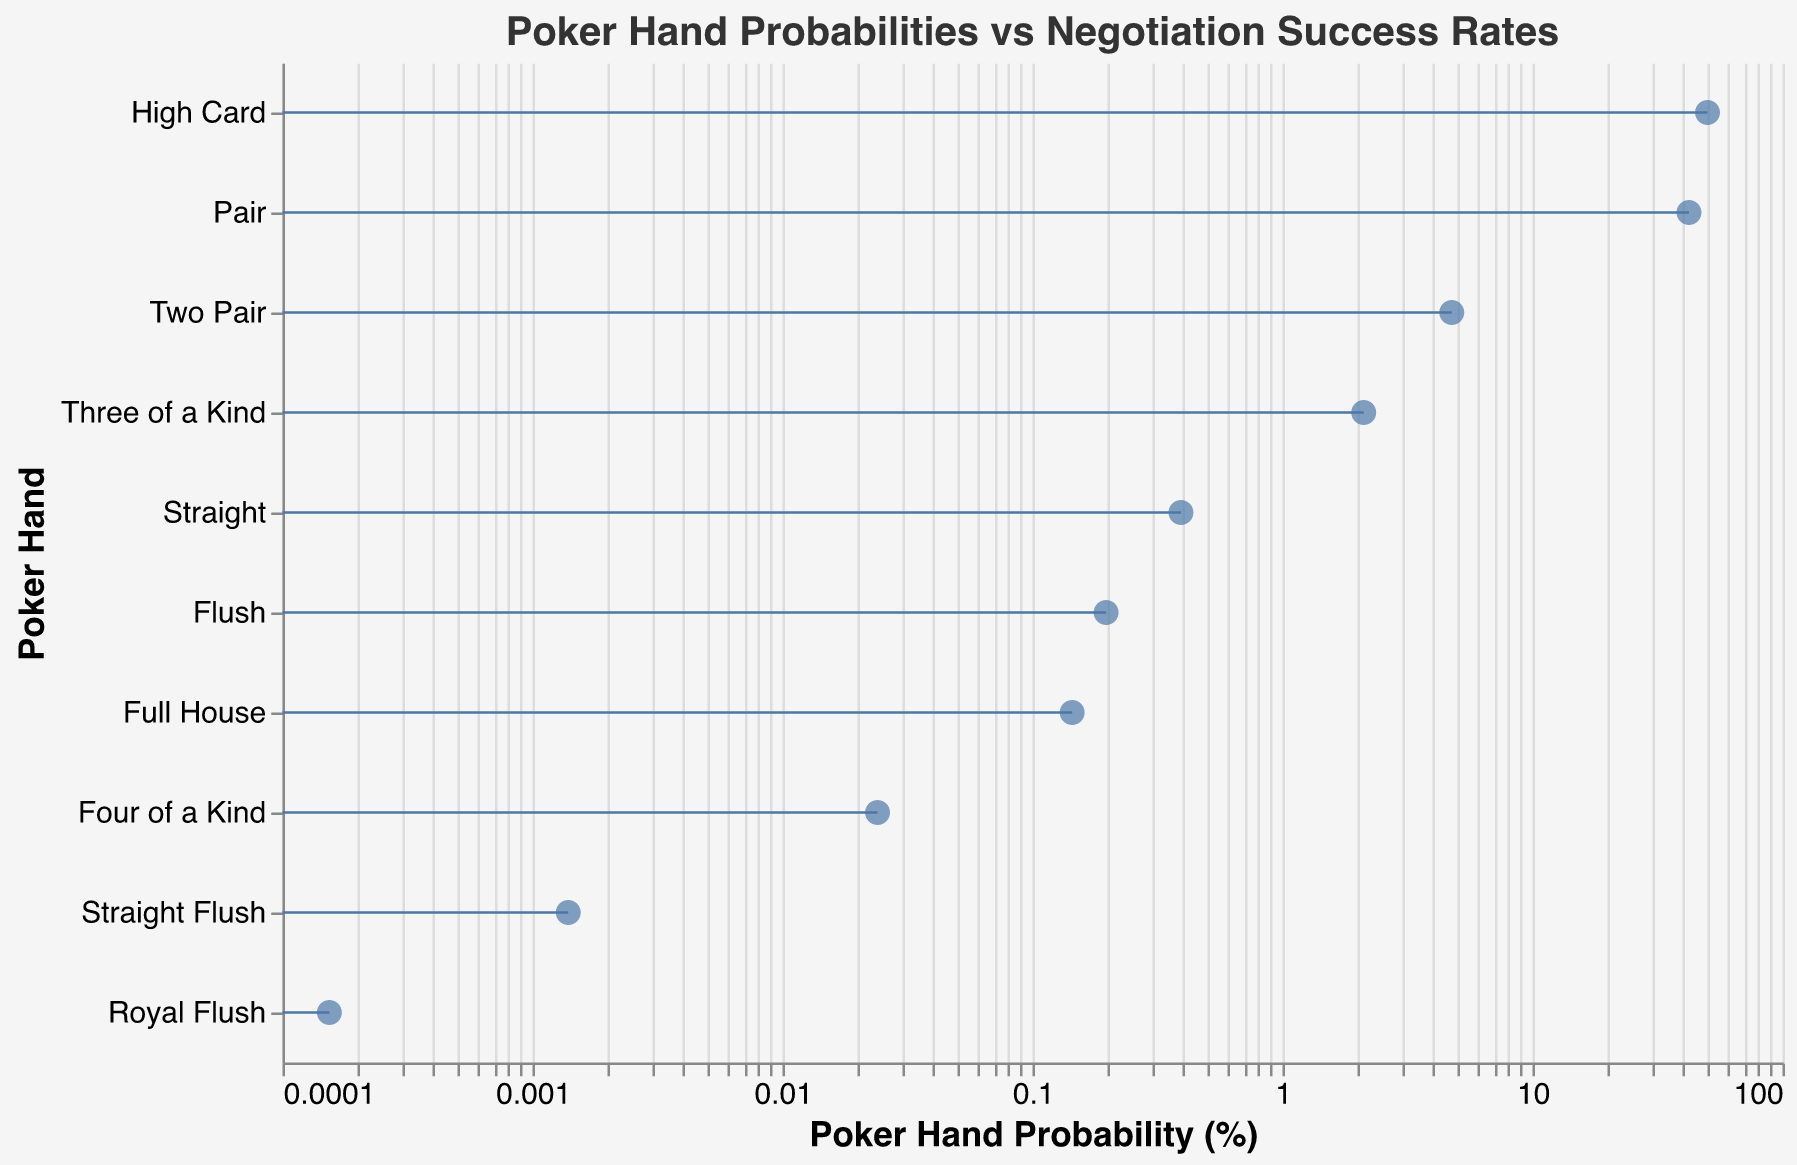What is the title of the figure? The title is usually displayed at the top of the figure and is meant to give a concise summary of what the figure is about. It is easily identifiable by its placement and font size. The title of the figure is "Poker Hand Probabilities vs Negotiation Success Rates".
Answer: Poker Hand Probabilities vs Negotiation Success Rates Which poker hand corresponds to a negotiation analogy of "Landing a High-Profile Client"? To determine this, look for the row where the "NegotiationAnalogy" column has the value "Landing a High-Profile Client" and find the corresponding "PokerHand". According to the data, the poker hand is "Straight Flush".
Answer: Straight Flush What is the probability percentage for a Full House hand? Locate the "Full House" row in the figure and read off the "Probability" value from the horizontal axis. The probability percentage for a Full House hand is 0.1441%.
Answer: 0.1441% Compare the success rates between "Securing a Merger with Top Competitor" and "Achieving a Strategic Acquisition". Which one has a higher success rate? Look for the rows corresponding to the negotiation analogies "Securing a Merger with Top Competitor" and "Achieving a Strategic Acquisition". Then compare their "SuccessRate" values. "Securing a Merger with Top Competitor" has a success rate of 75%, while "Achieving a Strategic Acquisition" has a lower success rate of 65%.
Answer: Securing a Merger with Top Competitor Calculate the average success rate for the negotiation scenarios "Closing a Major Partnership Deal" and "Winning a Difficult Contract". First, identify the "SuccessRate" values for "Closing a Major Partnership Deal" (90%) and "Winning a Difficult Contract" (80%). Then, calculate the average: (90 + 80) / 2 = 85%.
Answer: 85% Which negotiation outcome corresponds to the poker hand with the highest probability? Look for the poker hand with the highest "Probability" value and check its associated "NegotiationAnalogy". The hand "High Card" has the highest probability at 50.1177%, and its negotiation analogy is "Basic Service Level Agreement".
Answer: Basic Service Level Agreement Does "Three of a Kind" or "Two Pair" have a higher probability? Compare the "Probability" values of "Three of a Kind" (2.1128%) and "Two Pair" (4.7539%). The hand "Two Pair" has a higher probability.
Answer: Two Pair What is the success rate for "Completing a Routine Sales Negotiation"? Find the row with the negotiation analogy "Completing a Routine Sales Negotiation" and read off the "SuccessRate" value. The success rate is 40%.
Answer: 40% Identify the poker hand with a success rate of 70% in its negotiation analogy. Locate the row where the "SuccessRate" value is 70% and find the corresponding "PokerHand". The hand associated with a 70% success rate is "Flush".
Answer: Flush 